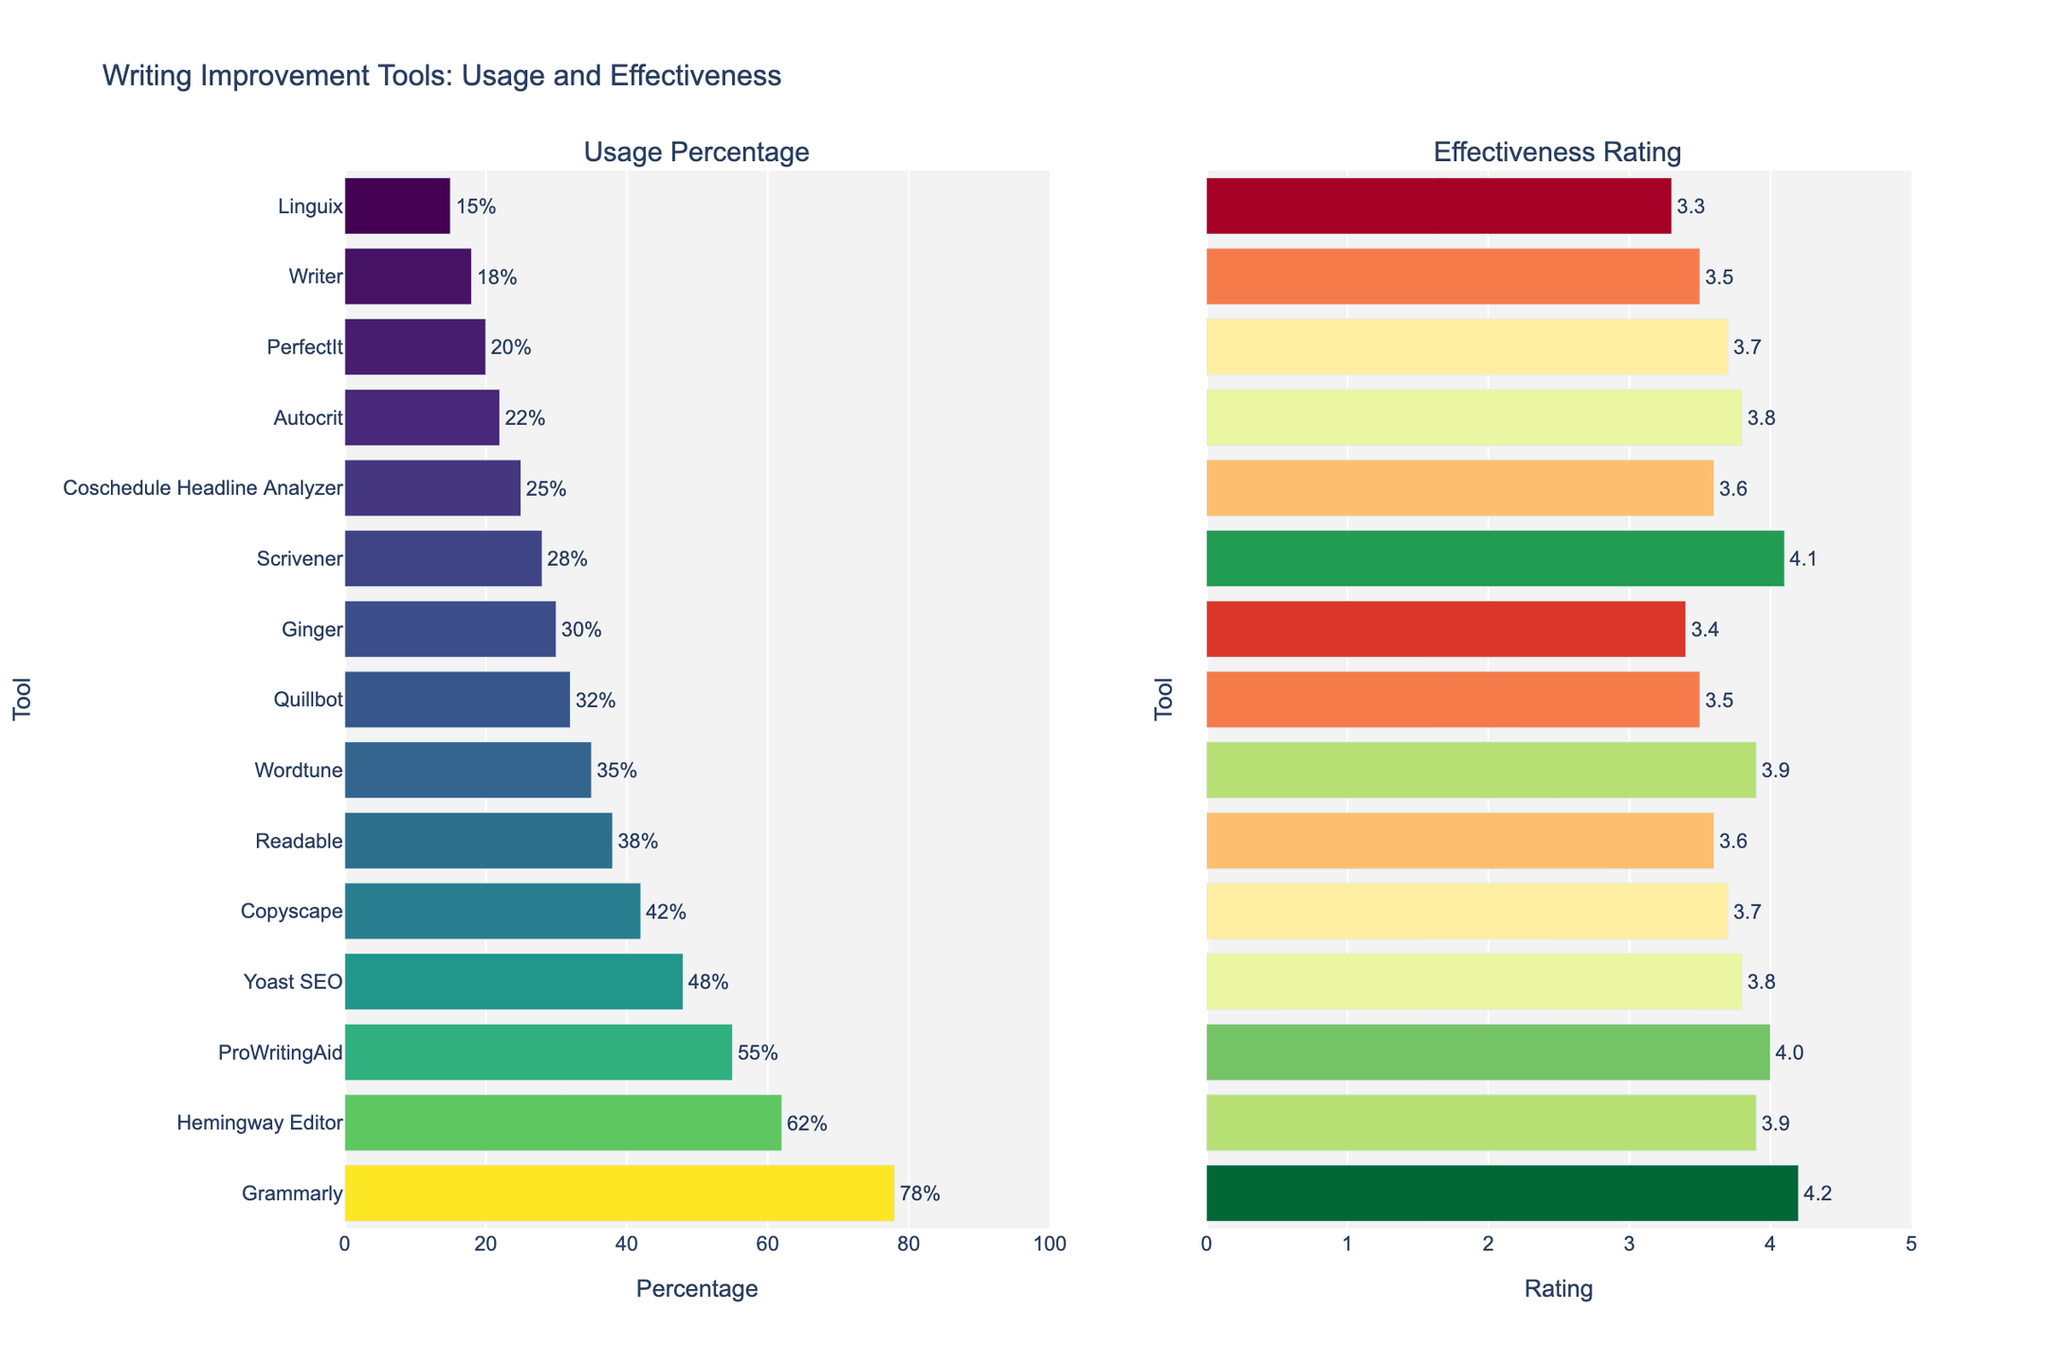Which tool has the highest usage percentage? The bar chart on the left shows the usage percentage for each tool. The bar with the highest value reaches 78%, which corresponds to Grammarly.
Answer: Grammarly Which tool has the lowest effectiveness rating? The bar chart on the right shows the effectiveness rating for each tool. The bar with the lowest value reaches 3.3, which corresponds to Linguix.
Answer: Linguix How much higher is Scrivener's effectiveness rating compared to Quillbot's? The bar chart on the right shows that Scrivener's effectiveness rating is 4.1 and Quillbot's is 3.5. The difference is 4.1 - 3.5 = 0.6.
Answer: 0.6 Which tool has a higher usage percentage: ProWritingAid or Yoast SEO? The bar chart on the left shows that ProWritingAid has a usage percentage of 55% and Yoast SEO has 48%. Therefore, ProWritingAid has a higher usage percentage.
Answer: ProWritingAid What is the average effectiveness rating for Grammarly, Hemingway Editor, and ProWritingAid? The effectiveness ratings are 4.2 for Grammarly, 3.9 for Hemingway Editor, and 4.0 for ProWritingAid. Sum these values: 4.2 + 3.9 + 4.0 = 12.1. The average is 12.1 / 3 = 4.03.
Answer: 4.03 Which tool has both a usage percentage greater than 60% and an effectiveness rating higher than 4.0? The bar chart shows that Grammarly and Hemingway Editor have usage percentages above 60%. Among these, Grammarly has an effectiveness rating of 4.2, which is higher than 4.0.
Answer: Grammarly Rank the top three tools by effectiveness rating. The bar chart on the right shows the effectiveness ratings. The top three ratings are 4.2 for Grammarly, 4.1 for Scrivener, and 4.0 for ProWritingAid.
Answer: Grammarly, Scrivener, ProWritingAid What is the total usage percentage for Grammarly, Hemingway Editor, and ProWritingAid combined? The usage percentages are 78% for Grammarly, 62% for Hemingway Editor, and 55% for ProWritingAid. Sum these values: 78 + 62 + 55 = 195%.
Answer: 195% Is there any tool with an effectiveness rating equal to 3.6? The bar chart on the right shows that both Readable and Coschedule Headline Analyzer have effectiveness ratings of 3.6.
Answer: Yes Do any tools have a usage percentage between 30% and 40%? The bar chart on the left shows that Wordtune (35%), Quillbot (32%), and Ginger (30%) have usage percentages within this range.
Answer: Yes 